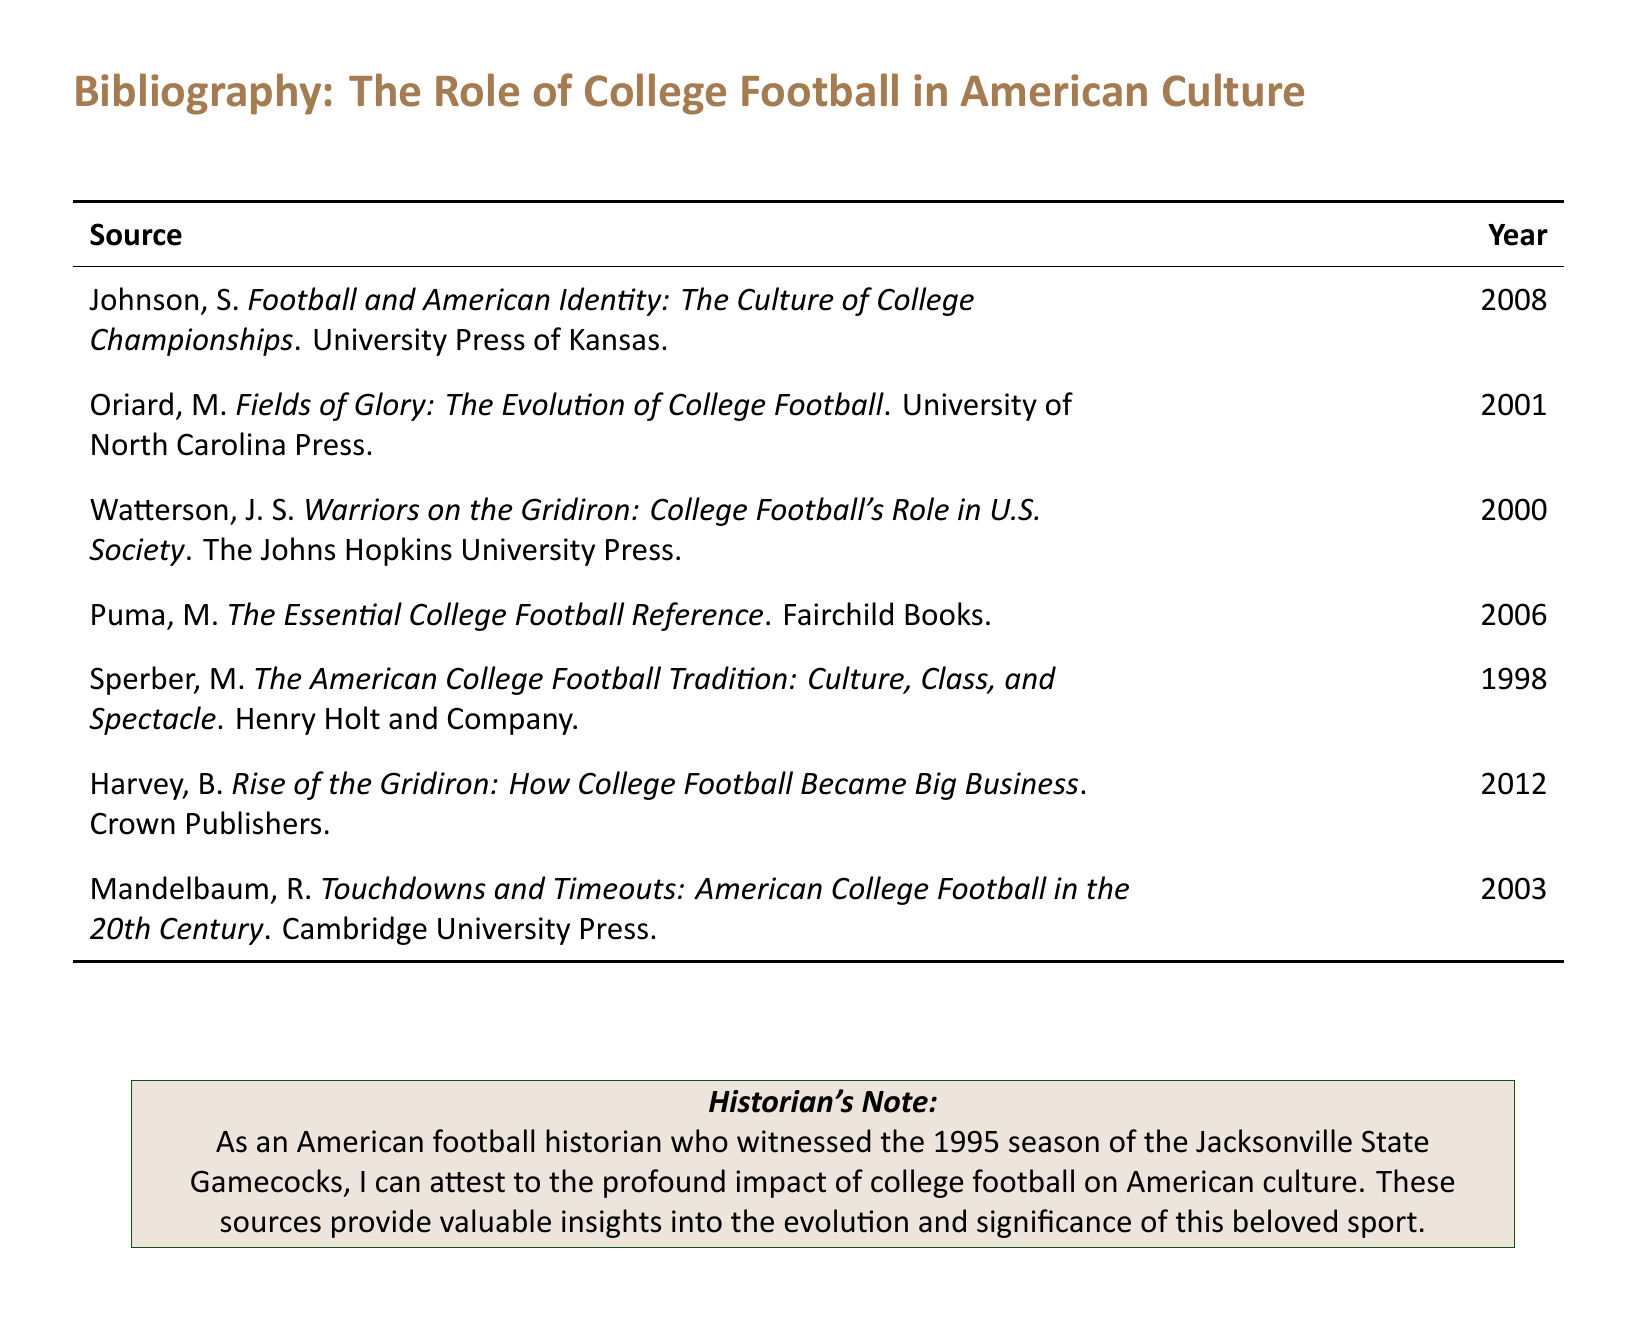What is the title of the source by S. Johnson? The title is listed in the bibliography section under S. Johnson's entry.
Answer: Football and American Identity: The Culture of College Championships What year was "Fields of Glory: The Evolution of College Football" published? The year is indicated next to the author and title in the bibliography.
Answer: 2001 Who published "The American College Football Tradition: Culture, Class, and Spectacle"? The publisher's name is included in the bibliography next to the title.
Answer: Henry Holt and Company What is the primary focus of the historiographical note? The historian's note summarizes the author's perspective on the topic of college football based on personal experience.
Answer: The profound impact of college football on American culture Which source was published most recently? The years of publication can be compared to determine which is the latest entry in the bibliography.
Answer: 2012 How many sources are listed in total? The total count of sources is determined by counting the entries in the bibliography.
Answer: 7 What color is used for the section titles in the document? The color is specified in the document's formatting instructions.
Answer: Football green Who authored "Rise of the Gridiron: How College Football Became Big Business"? This information is obtained from the bibliography, which provides author-listing details.
Answer: B. Harvey Which publisher produced the book "Touchdowns and Timeouts: American College Football in the 20th Century"? The publisher can be found directly next to the title in the bibliography section.
Answer: Cambridge University Press 